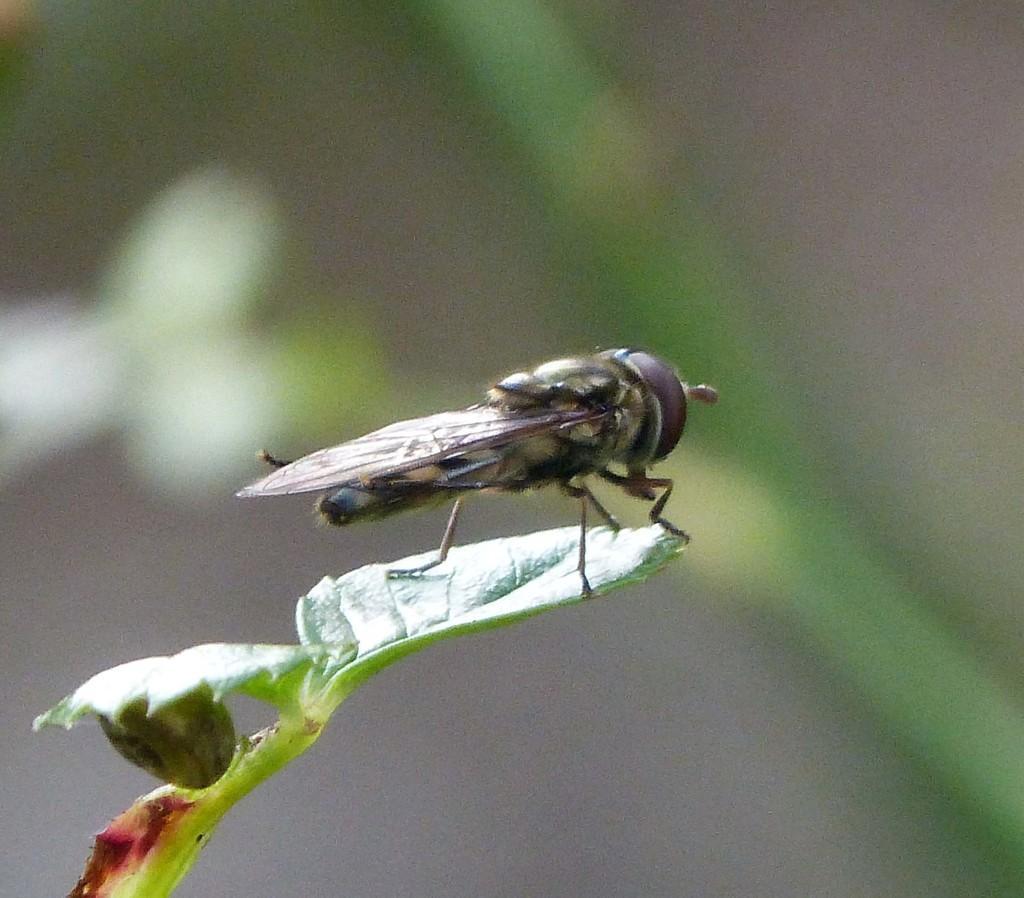Could you give a brief overview of what you see in this image? It's a house fly on the leaf of a plant. 